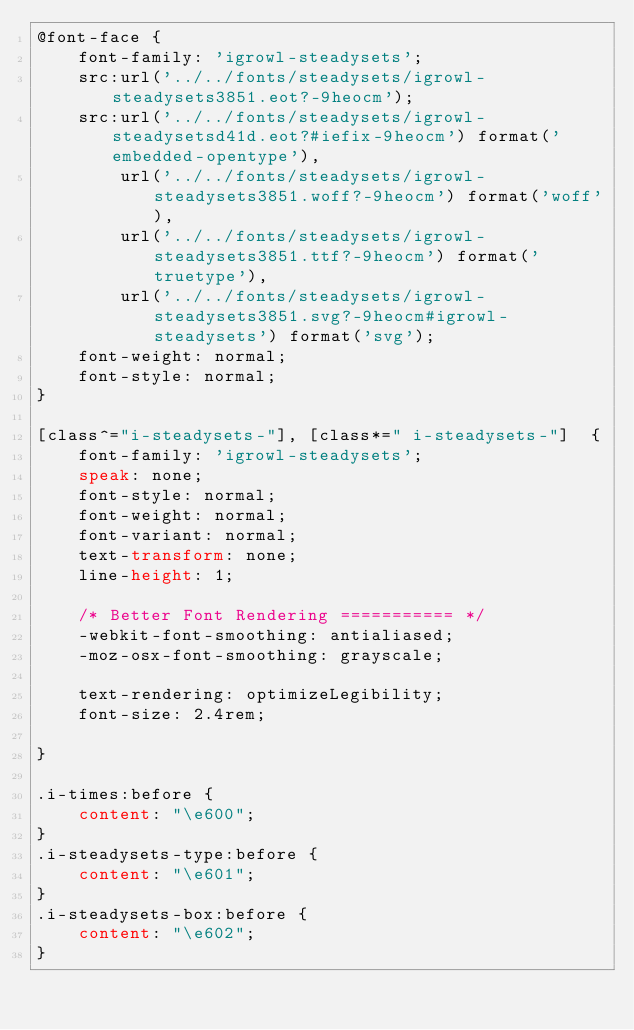<code> <loc_0><loc_0><loc_500><loc_500><_CSS_>@font-face {
	font-family: 'igrowl-steadysets';
	src:url('../../fonts/steadysets/igrowl-steadysets3851.eot?-9heocm');
	src:url('../../fonts/steadysets/igrowl-steadysetsd41d.eot?#iefix-9heocm') format('embedded-opentype'),
		url('../../fonts/steadysets/igrowl-steadysets3851.woff?-9heocm') format('woff'),
		url('../../fonts/steadysets/igrowl-steadysets3851.ttf?-9heocm') format('truetype'),
		url('../../fonts/steadysets/igrowl-steadysets3851.svg?-9heocm#igrowl-steadysets') format('svg');
	font-weight: normal;
	font-style: normal;
}

[class^="i-steadysets-"], [class*=" i-steadysets-"]  {
	font-family: 'igrowl-steadysets';
	speak: none;
	font-style: normal;
	font-weight: normal;
	font-variant: normal;
	text-transform: none;
	line-height: 1;

	/* Better Font Rendering =========== */
	-webkit-font-smoothing: antialiased;
	-moz-osx-font-smoothing: grayscale;

	text-rendering: optimizeLegibility;
	font-size: 2.4rem;

}

.i-times:before {
	content: "\e600";
}
.i-steadysets-type:before {
	content: "\e601";
}
.i-steadysets-box:before {
	content: "\e602";
}</code> 